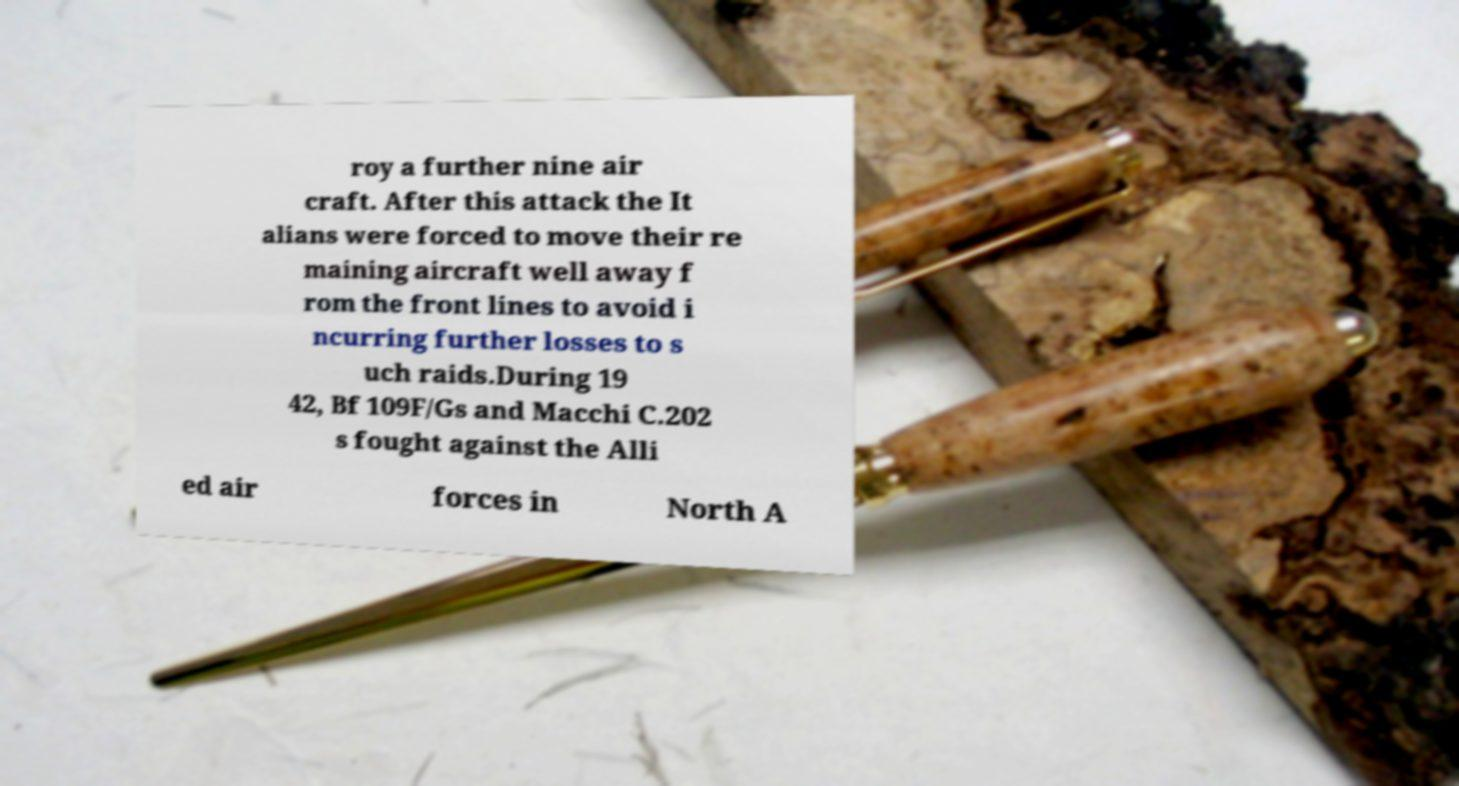Can you accurately transcribe the text from the provided image for me? roy a further nine air craft. After this attack the It alians were forced to move their re maining aircraft well away f rom the front lines to avoid i ncurring further losses to s uch raids.During 19 42, Bf 109F/Gs and Macchi C.202 s fought against the Alli ed air forces in North A 